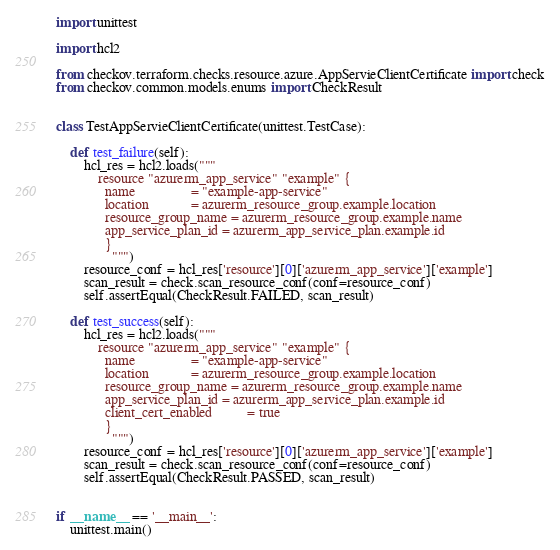<code> <loc_0><loc_0><loc_500><loc_500><_Python_>import unittest

import hcl2

from checkov.terraform.checks.resource.azure.AppServieClientCertificate import check
from checkov.common.models.enums import CheckResult


class TestAppServieClientCertificate(unittest.TestCase):

    def test_failure(self):
        hcl_res = hcl2.loads("""
            resource "azurerm_app_service" "example" {
              name                = "example-app-service"
              location            = azurerm_resource_group.example.location
              resource_group_name = azurerm_resource_group.example.name
              app_service_plan_id = azurerm_app_service_plan.example.id
              }
                """)
        resource_conf = hcl_res['resource'][0]['azurerm_app_service']['example']
        scan_result = check.scan_resource_conf(conf=resource_conf)
        self.assertEqual(CheckResult.FAILED, scan_result)

    def test_success(self):
        hcl_res = hcl2.loads("""
            resource "azurerm_app_service" "example" {
              name                = "example-app-service"
              location            = azurerm_resource_group.example.location
              resource_group_name = azurerm_resource_group.example.name
              app_service_plan_id = azurerm_app_service_plan.example.id
              client_cert_enabled          = true
              }
                """)
        resource_conf = hcl_res['resource'][0]['azurerm_app_service']['example']
        scan_result = check.scan_resource_conf(conf=resource_conf)
        self.assertEqual(CheckResult.PASSED, scan_result)


if __name__ == '__main__':
    unittest.main()
</code> 